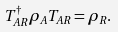<formula> <loc_0><loc_0><loc_500><loc_500>T _ { A R } ^ { \dagger } \rho _ { A } T _ { A R } = \rho _ { R } .</formula> 